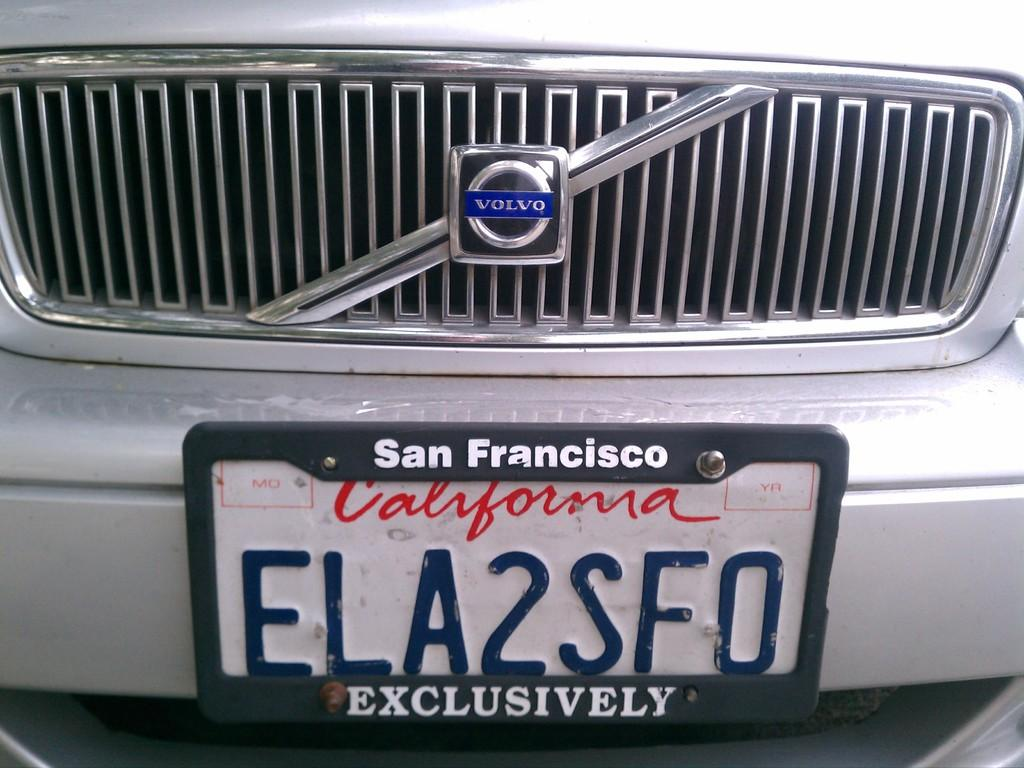<image>
Offer a succinct explanation of the picture presented. A Volvo has a California plate that states ELA2SFO. 